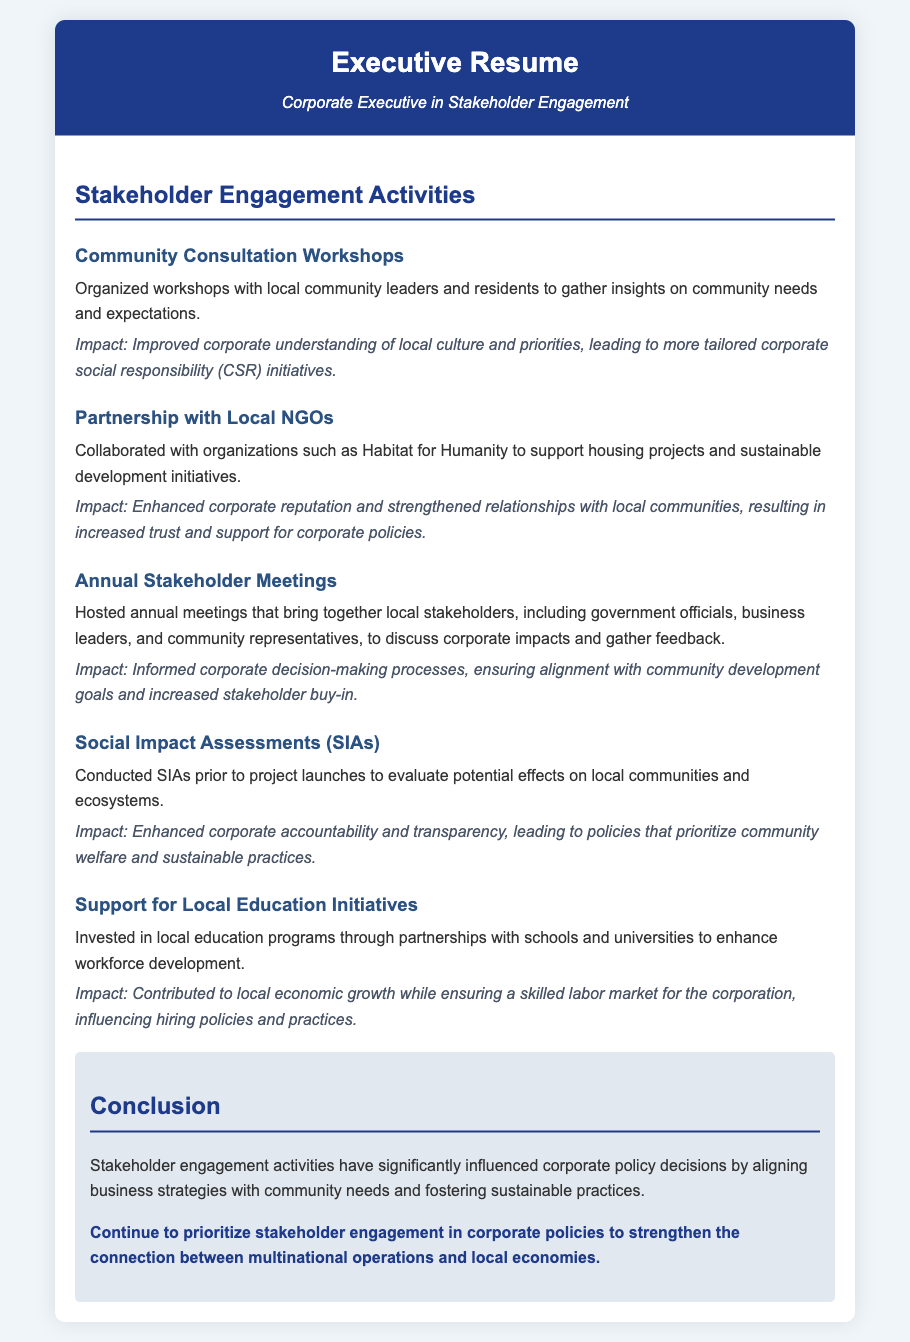What is one of the community engagement activities mentioned? The document lists several activities focusing on stakeholder engagement, including workshops and partnerships.
Answer: Community Consultation Workshops What is the impact of partnering with local NGOs? The document states that collaboration enhances corporate reputation and strengthens relationships with communities.
Answer: Enhanced corporate reputation How often are annual stakeholder meetings held? The document implies these meetings are organized on a yearly basis.
Answer: Annual What is one purpose of Social Impact Assessments (SIAs)? The document describes SIAs as tools to evaluate potential effects on local communities prior to project launches.
Answer: Evaluate potential effects Which initiative supports local education? The document mentions investments in education programs as a way to enhance workforce development.
Answer: Support for Local Education Initiatives What is emphasized for corporate policy in the conclusion? The conclusion indicates a focus on maintaining stakeholder engagement to align business strategies with community needs.
Answer: Prioritize stakeholder engagement 